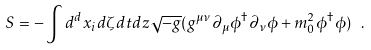<formula> <loc_0><loc_0><loc_500><loc_500>S = - \int d ^ { d } x _ { i } d \zeta d t d z \sqrt { - g } ( g ^ { \mu \nu } \partial _ { \mu } \phi ^ { \dagger } \partial _ { \nu } \phi + m _ { 0 } ^ { 2 } \phi ^ { \dagger } \phi ) \ .</formula> 